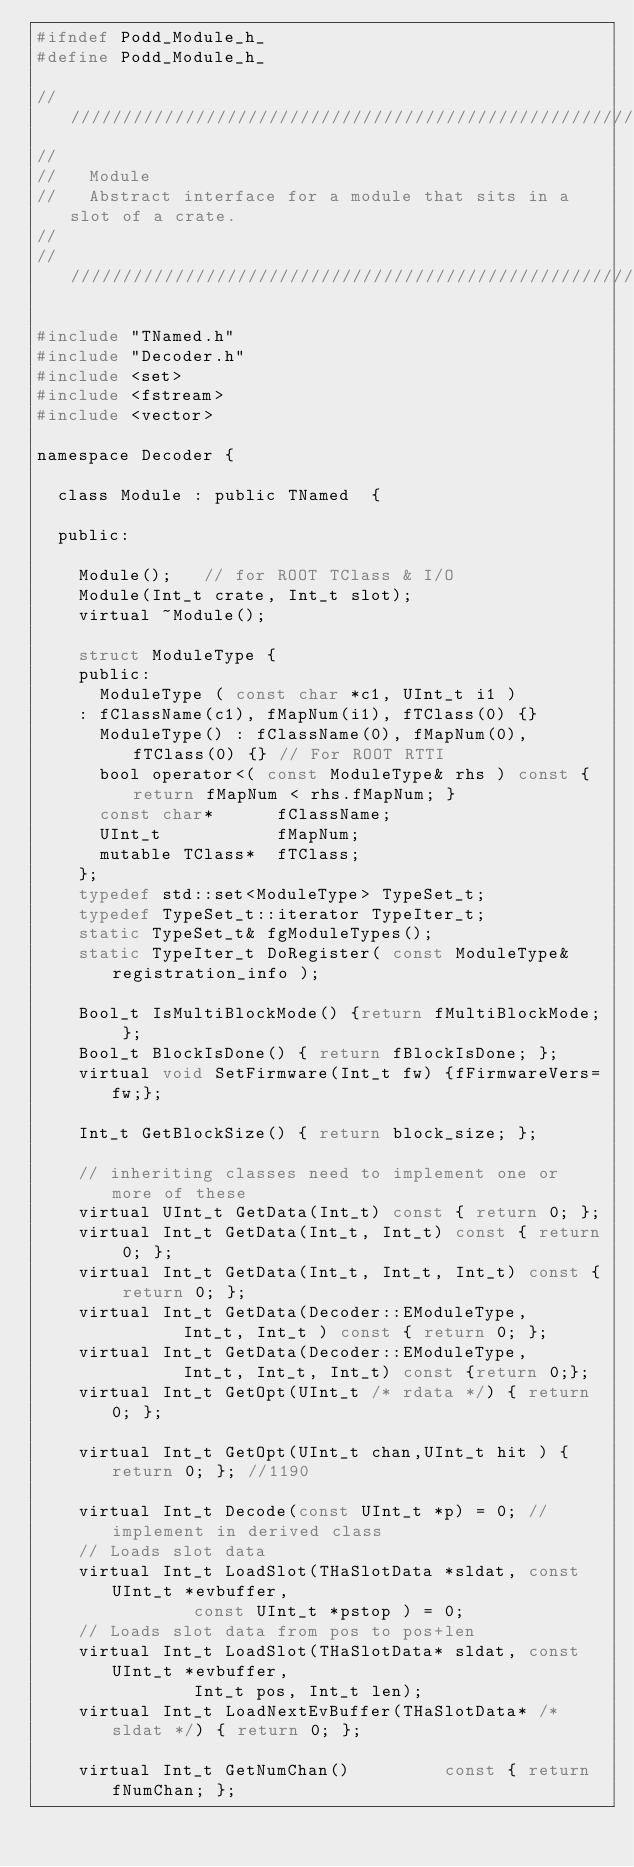<code> <loc_0><loc_0><loc_500><loc_500><_C_>#ifndef Podd_Module_h_
#define Podd_Module_h_

/////////////////////////////////////////////////////////////////////
//
//   Module
//   Abstract interface for a module that sits in a slot of a crate.
//
/////////////////////////////////////////////////////////////////////

#include "TNamed.h"
#include "Decoder.h"
#include <set>
#include <fstream>
#include <vector>

namespace Decoder {

  class Module : public TNamed  {

  public:

    Module();   // for ROOT TClass & I/O
    Module(Int_t crate, Int_t slot);
    virtual ~Module();

    struct ModuleType {
    public:
      ModuleType ( const char *c1, UInt_t i1 )
	: fClassName(c1), fMapNum(i1), fTClass(0) {}
      ModuleType() : fClassName(0), fMapNum(0), fTClass(0) {} // For ROOT RTTI
      bool operator<( const ModuleType& rhs ) const { return fMapNum < rhs.fMapNum; }
      const char*      fClassName;
      UInt_t           fMapNum;
      mutable TClass*  fTClass;
    };
    typedef std::set<ModuleType> TypeSet_t;
    typedef TypeSet_t::iterator TypeIter_t;
    static TypeSet_t& fgModuleTypes();
    static TypeIter_t DoRegister( const ModuleType& registration_info );

    Bool_t IsMultiBlockMode() {return fMultiBlockMode; };
    Bool_t BlockIsDone() { return fBlockIsDone; };
    virtual void SetFirmware(Int_t fw) {fFirmwareVers=fw;};

    Int_t GetBlockSize() { return block_size; };

    // inheriting classes need to implement one or more of these
    virtual UInt_t GetData(Int_t) const { return 0; };
    virtual Int_t GetData(Int_t, Int_t) const { return 0; };
    virtual Int_t GetData(Int_t, Int_t, Int_t) const { return 0; };
    virtual Int_t GetData(Decoder::EModuleType,
			  Int_t, Int_t ) const { return 0; };
    virtual Int_t GetData(Decoder::EModuleType,
			  Int_t, Int_t, Int_t) const {return 0;};
    virtual Int_t GetOpt(UInt_t /* rdata */) { return 0; };

    virtual Int_t GetOpt(UInt_t chan,UInt_t hit ) { return 0; }; //1190

    virtual Int_t Decode(const UInt_t *p) = 0; // implement in derived class
    // Loads slot data
    virtual Int_t LoadSlot(THaSlotData *sldat, const UInt_t *evbuffer,
			   const UInt_t *pstop ) = 0;
    // Loads slot data from pos to pos+len
    virtual Int_t LoadSlot(THaSlotData* sldat, const UInt_t *evbuffer,
			   Int_t pos, Int_t len);
    virtual Int_t LoadNextEvBuffer(THaSlotData* /* sldat */) { return 0; };

    virtual Int_t GetNumChan()         const { return fNumChan; };
</code> 